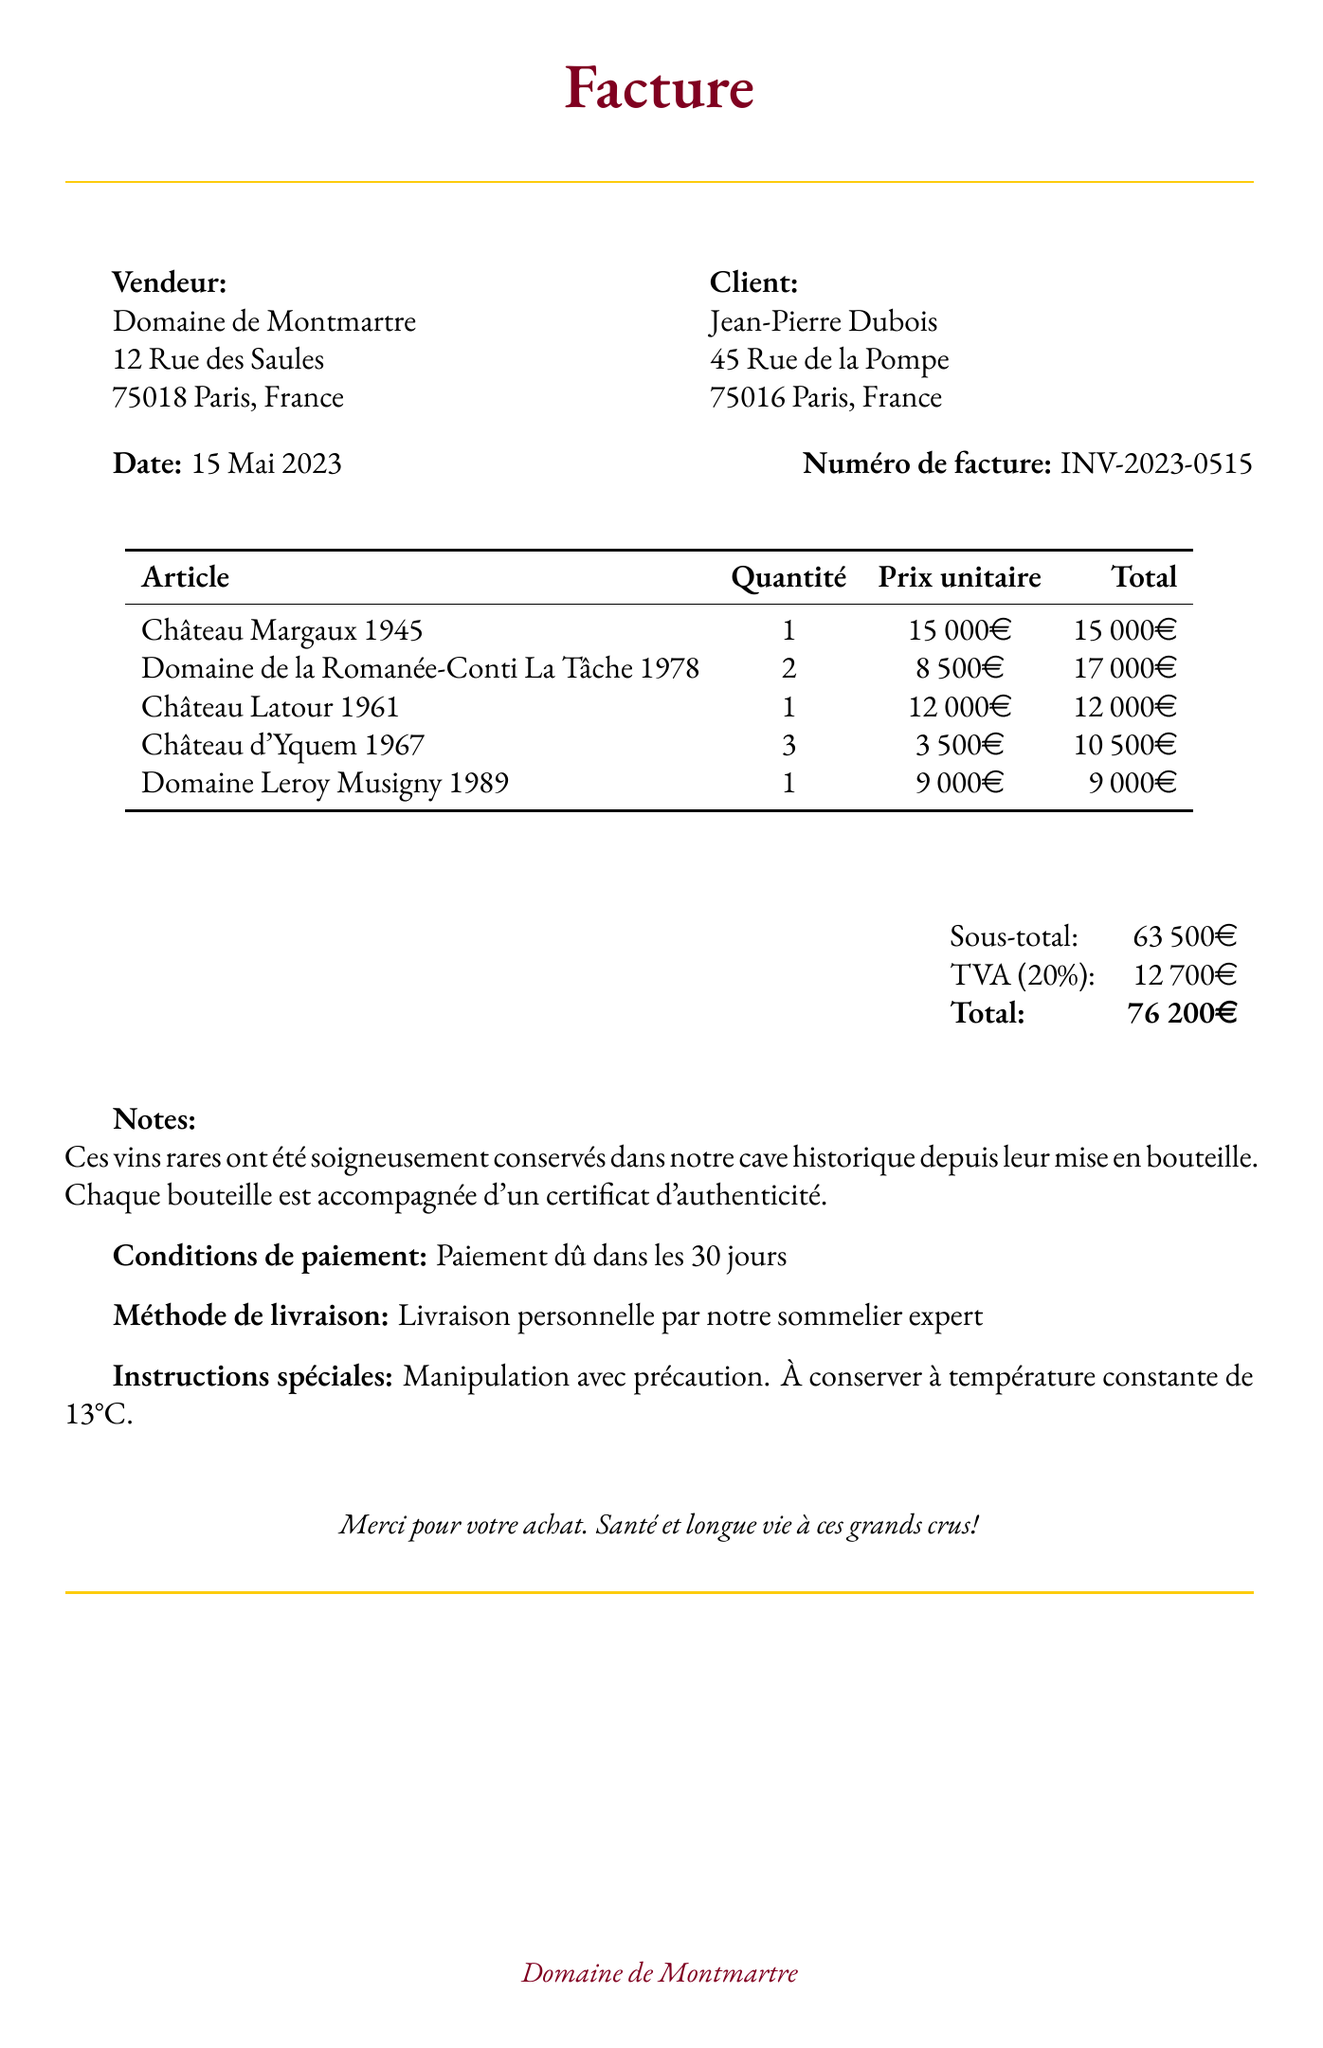What is the name of the vendor? The vendor's name is given in the document as the seller of the wine.
Answer: Domaine de Montmartre What is the invoice date? The document specifies the date the invoice was issued.
Answer: 15 Mai 2023 How many bottles of Château d'Yquem 1967 were purchased? The invoice lists the quantity of this specific wine purchased.
Answer: 3 What is the total amount due? The total amount is the sum of the subtotal and tax listed in the invoice.
Answer: 76 200€ Which bottle is the oldest in the purchase? The invoice provides the year of each bottle, identifying the oldest one.
Answer: Château Margaux 1945 What is the payment term specified in the invoice? The document states the conditions under which payment is due.
Answer: Paiement dû dans les 30 jours How much tax was applied to the purchase? The invoice lists the tax amount calculated on the subtotal.
Answer: 12 700€ What is the delivery method? The invoice indicates how the purchase will be delivered to the customer.
Answer: Livraison personnelle par notre sommelier expert 